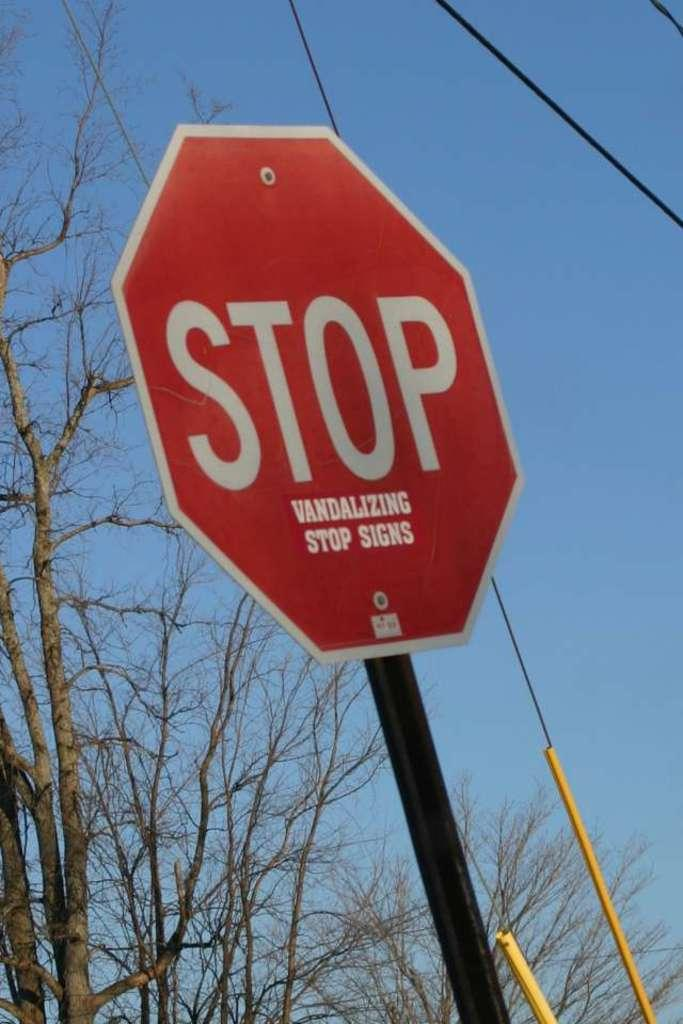<image>
Share a concise interpretation of the image provided. A stop sign with a sticker that says Vandalizing stop signs below the word stop. 